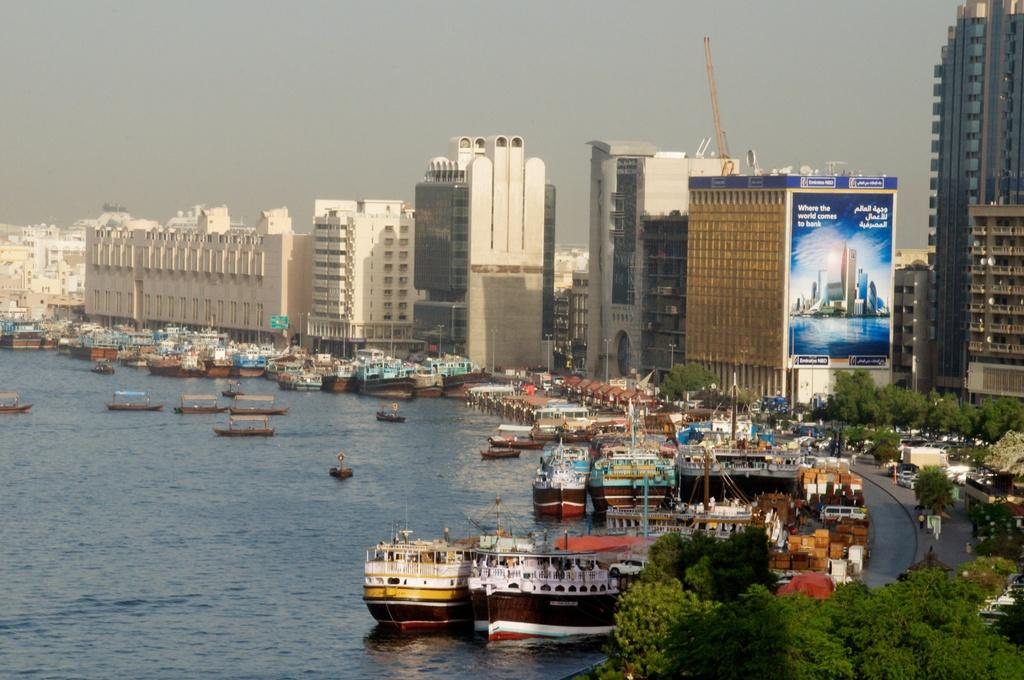What is the main subject of the image? The main subject of the image is a group of boats on water. What else can be seen in the image besides the boats? There are vehicles on the road, trees, boxes, banners, buildings, poles, and the sky visible in the image. Can you describe the vehicles in the image? The vehicles are on the road, but their specific types are not mentioned in the facts. What is the color of the sky in the image? The color of the sky is not mentioned in the facts. What type of food is being prepared on the boats in the image? There is no mention of food or cooking in the image, so it cannot be determined from the facts. 